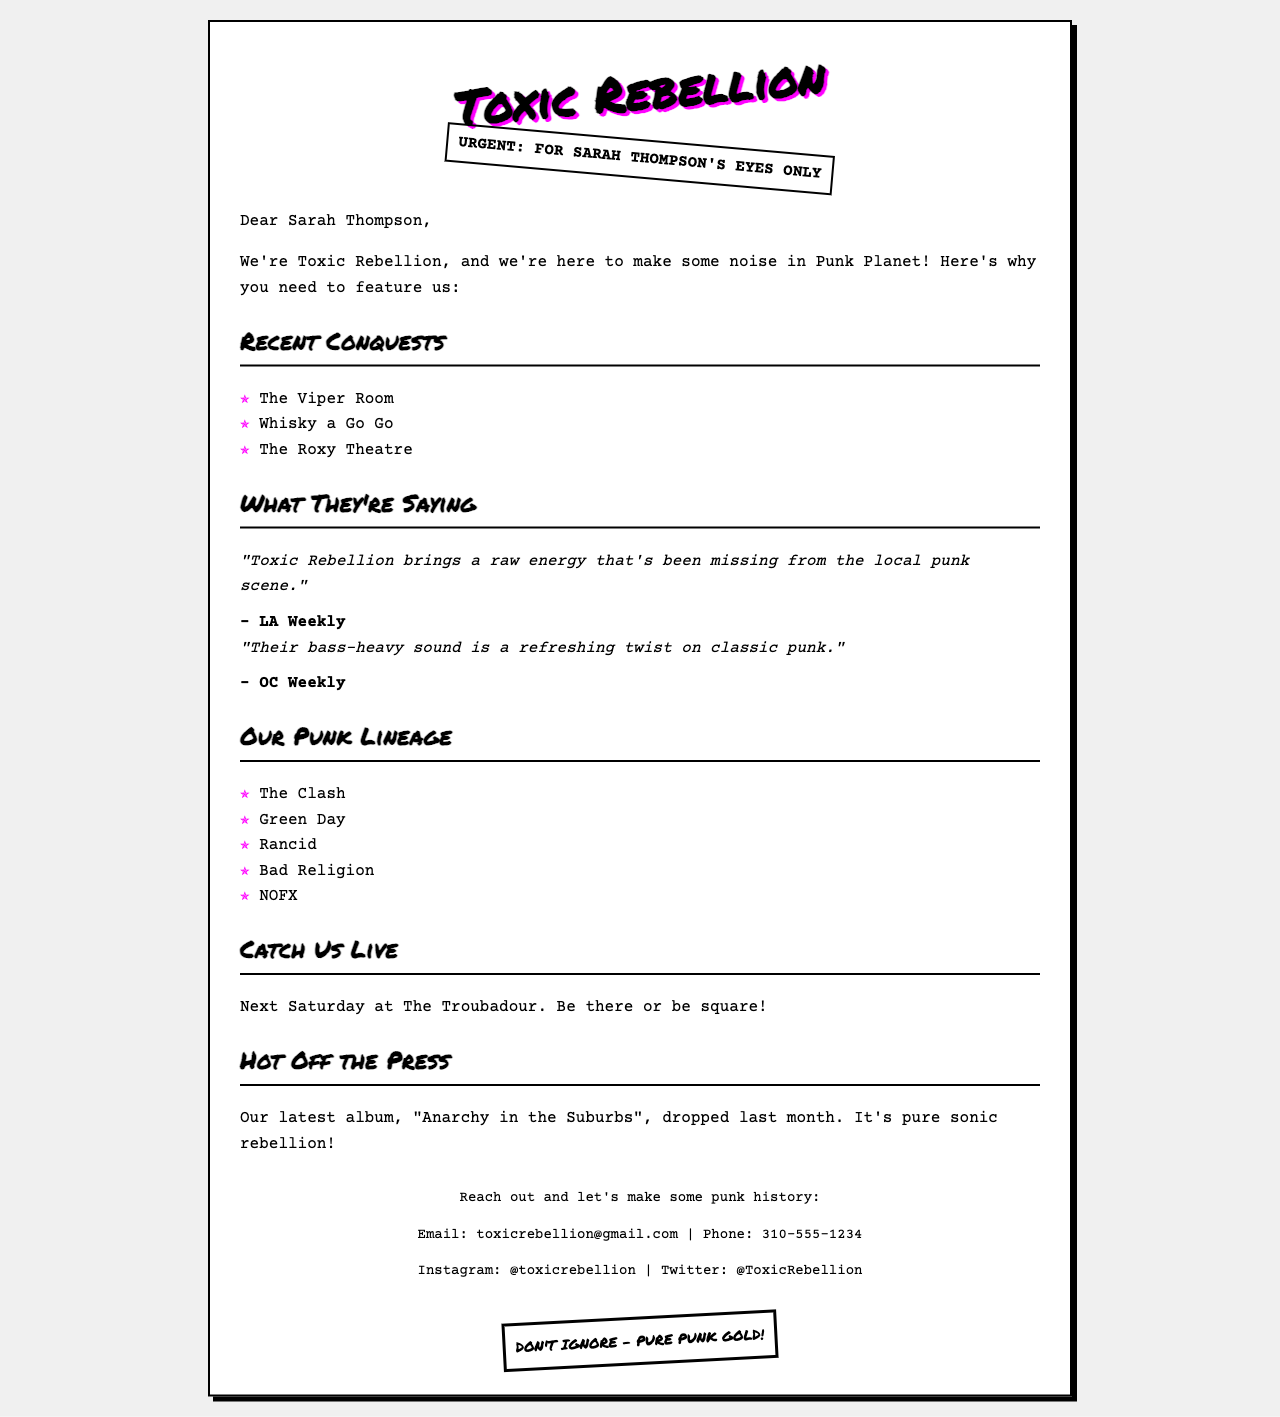what is the name of the band? The name of the band is mentioned at the top of the document.
Answer: Toxic Rebellion who is the fax addressed to? The fax is addressed to Sarah Thompson, as stated in the opening line.
Answer: Sarah Thompson what venue will the band perform at next Saturday? The venue for their next performance is listed in the section about catching them live.
Answer: The Troubadour what is the title of the band's latest album? The title of the latest album is provided under the "Hot Off the Press" section.
Answer: Anarchy in the Suburbs which publication mentioned the band's raw energy? The publication that mentioned the band's raw energy is noted in the "What They're Saying" section.
Answer: LA Weekly how many venues are listed under "Recent Conquests"? The number of venues mentioned can be counted in the respective section.
Answer: 3 which band is NOT on the list of influences? The bands listed under "Our Punk Lineage" contain specific examples, and one can identify the absence of other notable bands.
Answer: Blink-182 what does the document indicate about the band's sound? The document describes the band's sound as a specific twist, found in the quotes about what others say.
Answer: Bass-heavy what type of document is this? The format and content of the message indicate its purpose.
Answer: Fax 